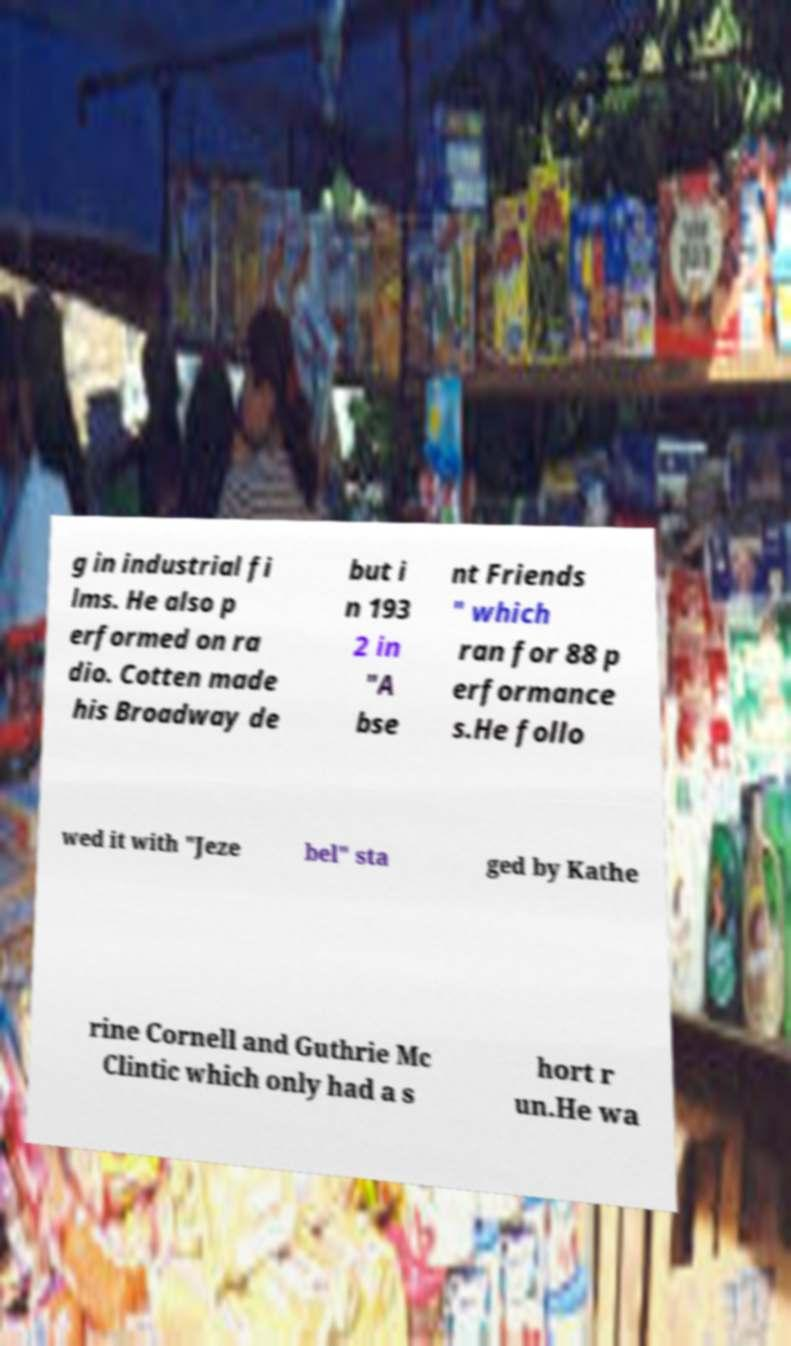Can you read and provide the text displayed in the image?This photo seems to have some interesting text. Can you extract and type it out for me? g in industrial fi lms. He also p erformed on ra dio. Cotten made his Broadway de but i n 193 2 in "A bse nt Friends " which ran for 88 p erformance s.He follo wed it with "Jeze bel" sta ged by Kathe rine Cornell and Guthrie Mc Clintic which only had a s hort r un.He wa 